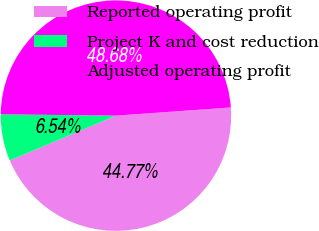Convert chart. <chart><loc_0><loc_0><loc_500><loc_500><pie_chart><fcel>Reported operating profit<fcel>Project K and cost reduction<fcel>Adjusted operating profit<nl><fcel>44.77%<fcel>6.54%<fcel>48.68%<nl></chart> 